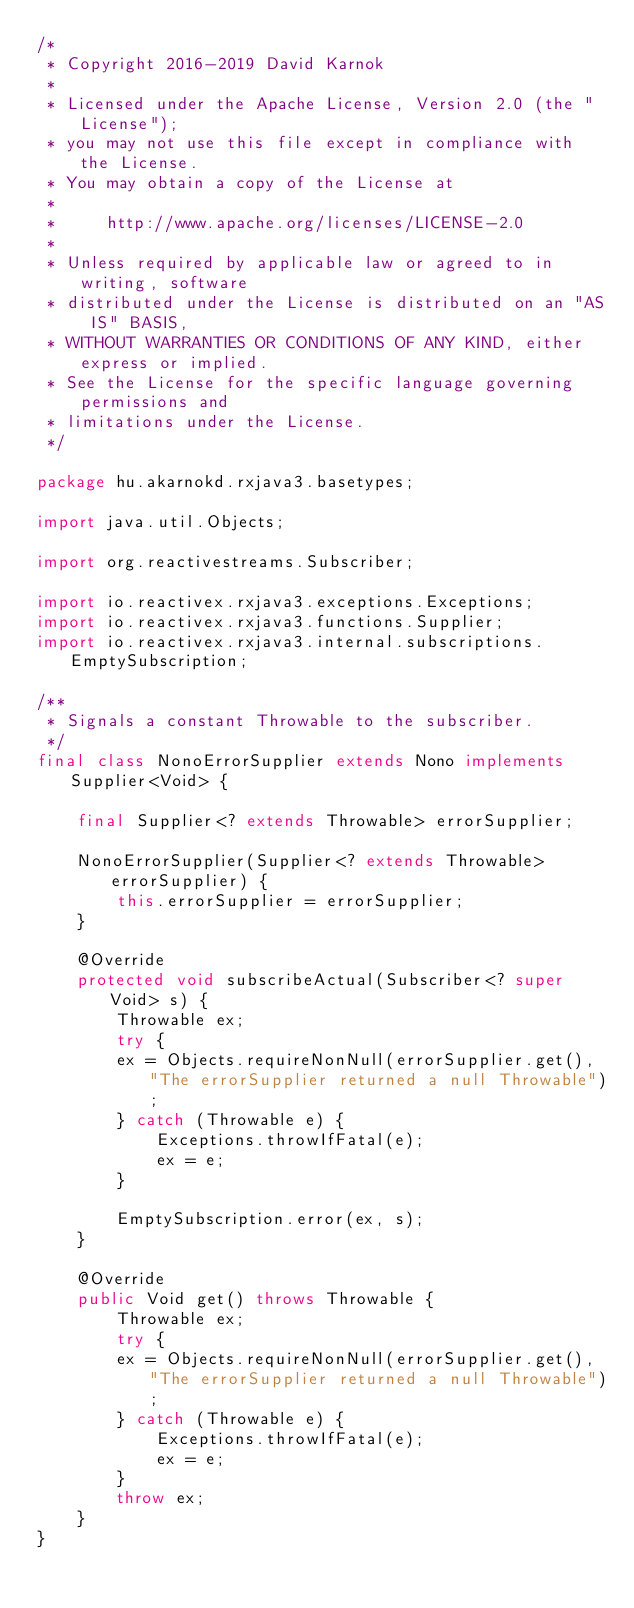<code> <loc_0><loc_0><loc_500><loc_500><_Java_>/*
 * Copyright 2016-2019 David Karnok
 *
 * Licensed under the Apache License, Version 2.0 (the "License");
 * you may not use this file except in compliance with the License.
 * You may obtain a copy of the License at
 *
 *     http://www.apache.org/licenses/LICENSE-2.0
 *
 * Unless required by applicable law or agreed to in writing, software
 * distributed under the License is distributed on an "AS IS" BASIS,
 * WITHOUT WARRANTIES OR CONDITIONS OF ANY KIND, either express or implied.
 * See the License for the specific language governing permissions and
 * limitations under the License.
 */

package hu.akarnokd.rxjava3.basetypes;

import java.util.Objects;

import org.reactivestreams.Subscriber;

import io.reactivex.rxjava3.exceptions.Exceptions;
import io.reactivex.rxjava3.functions.Supplier;
import io.reactivex.rxjava3.internal.subscriptions.EmptySubscription;

/**
 * Signals a constant Throwable to the subscriber.
 */
final class NonoErrorSupplier extends Nono implements Supplier<Void> {

    final Supplier<? extends Throwable> errorSupplier;

    NonoErrorSupplier(Supplier<? extends Throwable> errorSupplier) {
        this.errorSupplier = errorSupplier;
    }

    @Override
    protected void subscribeActual(Subscriber<? super Void> s) {
        Throwable ex;
        try {
        ex = Objects.requireNonNull(errorSupplier.get(), "The errorSupplier returned a null Throwable");
        } catch (Throwable e) {
            Exceptions.throwIfFatal(e);
            ex = e;
        }

        EmptySubscription.error(ex, s);
    }

    @Override
    public Void get() throws Throwable {
        Throwable ex;
        try {
        ex = Objects.requireNonNull(errorSupplier.get(), "The errorSupplier returned a null Throwable");
        } catch (Throwable e) {
            Exceptions.throwIfFatal(e);
            ex = e;
        }
        throw ex;
    }
}
</code> 